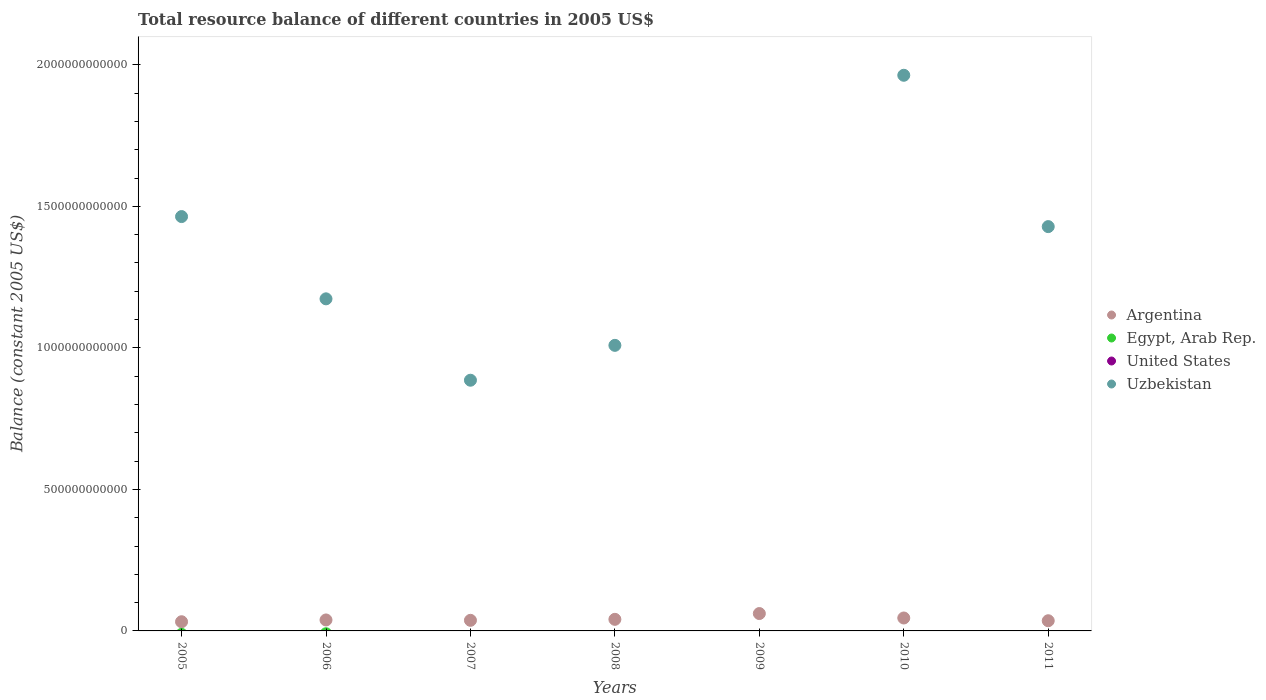How many different coloured dotlines are there?
Provide a succinct answer. 2. Is the number of dotlines equal to the number of legend labels?
Your answer should be compact. No. What is the total resource balance in Uzbekistan in 2005?
Make the answer very short. 1.46e+12. Across all years, what is the maximum total resource balance in Uzbekistan?
Give a very brief answer. 1.96e+12. Across all years, what is the minimum total resource balance in Egypt, Arab Rep.?
Offer a terse response. 0. What is the difference between the total resource balance in Argentina in 2008 and that in 2009?
Your answer should be very brief. -2.04e+1. What is the difference between the total resource balance in Uzbekistan in 2005 and the total resource balance in United States in 2007?
Your answer should be very brief. 1.46e+12. In the year 2010, what is the difference between the total resource balance in Uzbekistan and total resource balance in Argentina?
Provide a succinct answer. 1.92e+12. In how many years, is the total resource balance in Egypt, Arab Rep. greater than 100000000000 US$?
Keep it short and to the point. 0. What is the ratio of the total resource balance in Uzbekistan in 2005 to that in 2008?
Your answer should be very brief. 1.45. Is the total resource balance in Argentina in 2005 less than that in 2006?
Keep it short and to the point. Yes. What is the difference between the highest and the second highest total resource balance in Argentina?
Offer a very short reply. 1.57e+1. In how many years, is the total resource balance in Uzbekistan greater than the average total resource balance in Uzbekistan taken over all years?
Provide a succinct answer. 4. Is the sum of the total resource balance in Argentina in 2005 and 2008 greater than the maximum total resource balance in Egypt, Arab Rep. across all years?
Ensure brevity in your answer.  Yes. Is it the case that in every year, the sum of the total resource balance in Argentina and total resource balance in United States  is greater than the total resource balance in Egypt, Arab Rep.?
Provide a succinct answer. Yes. Does the total resource balance in Argentina monotonically increase over the years?
Keep it short and to the point. No. Is the total resource balance in Egypt, Arab Rep. strictly greater than the total resource balance in United States over the years?
Your response must be concise. Yes. What is the difference between two consecutive major ticks on the Y-axis?
Your answer should be very brief. 5.00e+11. Are the values on the major ticks of Y-axis written in scientific E-notation?
Provide a succinct answer. No. Does the graph contain any zero values?
Offer a terse response. Yes. Where does the legend appear in the graph?
Your answer should be compact. Center right. How are the legend labels stacked?
Give a very brief answer. Vertical. What is the title of the graph?
Your answer should be very brief. Total resource balance of different countries in 2005 US$. What is the label or title of the X-axis?
Make the answer very short. Years. What is the label or title of the Y-axis?
Your response must be concise. Balance (constant 2005 US$). What is the Balance (constant 2005 US$) of Argentina in 2005?
Provide a succinct answer. 3.24e+1. What is the Balance (constant 2005 US$) in Egypt, Arab Rep. in 2005?
Offer a terse response. 0. What is the Balance (constant 2005 US$) of Uzbekistan in 2005?
Make the answer very short. 1.46e+12. What is the Balance (constant 2005 US$) of Argentina in 2006?
Ensure brevity in your answer.  3.87e+1. What is the Balance (constant 2005 US$) in Egypt, Arab Rep. in 2006?
Give a very brief answer. 0. What is the Balance (constant 2005 US$) of Uzbekistan in 2006?
Your response must be concise. 1.17e+12. What is the Balance (constant 2005 US$) of Argentina in 2007?
Your response must be concise. 3.74e+1. What is the Balance (constant 2005 US$) in United States in 2007?
Make the answer very short. 0. What is the Balance (constant 2005 US$) of Uzbekistan in 2007?
Ensure brevity in your answer.  8.86e+11. What is the Balance (constant 2005 US$) in Argentina in 2008?
Provide a short and direct response. 4.09e+1. What is the Balance (constant 2005 US$) of Egypt, Arab Rep. in 2008?
Keep it short and to the point. 0. What is the Balance (constant 2005 US$) of United States in 2008?
Your answer should be compact. 0. What is the Balance (constant 2005 US$) of Uzbekistan in 2008?
Keep it short and to the point. 1.01e+12. What is the Balance (constant 2005 US$) of Argentina in 2009?
Your answer should be very brief. 6.14e+1. What is the Balance (constant 2005 US$) in Argentina in 2010?
Make the answer very short. 4.57e+1. What is the Balance (constant 2005 US$) in United States in 2010?
Provide a succinct answer. 0. What is the Balance (constant 2005 US$) in Uzbekistan in 2010?
Your answer should be compact. 1.96e+12. What is the Balance (constant 2005 US$) of Argentina in 2011?
Offer a very short reply. 3.60e+1. What is the Balance (constant 2005 US$) in Uzbekistan in 2011?
Your response must be concise. 1.43e+12. Across all years, what is the maximum Balance (constant 2005 US$) in Argentina?
Offer a terse response. 6.14e+1. Across all years, what is the maximum Balance (constant 2005 US$) of Uzbekistan?
Provide a succinct answer. 1.96e+12. Across all years, what is the minimum Balance (constant 2005 US$) of Argentina?
Make the answer very short. 3.24e+1. Across all years, what is the minimum Balance (constant 2005 US$) of Uzbekistan?
Your response must be concise. 0. What is the total Balance (constant 2005 US$) of Argentina in the graph?
Keep it short and to the point. 2.93e+11. What is the total Balance (constant 2005 US$) in Egypt, Arab Rep. in the graph?
Give a very brief answer. 0. What is the total Balance (constant 2005 US$) of Uzbekistan in the graph?
Your response must be concise. 7.92e+12. What is the difference between the Balance (constant 2005 US$) of Argentina in 2005 and that in 2006?
Your answer should be very brief. -6.29e+09. What is the difference between the Balance (constant 2005 US$) in Uzbekistan in 2005 and that in 2006?
Offer a very short reply. 2.91e+11. What is the difference between the Balance (constant 2005 US$) in Argentina in 2005 and that in 2007?
Ensure brevity in your answer.  -5.00e+09. What is the difference between the Balance (constant 2005 US$) of Uzbekistan in 2005 and that in 2007?
Your answer should be very brief. 5.78e+11. What is the difference between the Balance (constant 2005 US$) in Argentina in 2005 and that in 2008?
Offer a very short reply. -8.49e+09. What is the difference between the Balance (constant 2005 US$) in Uzbekistan in 2005 and that in 2008?
Make the answer very short. 4.55e+11. What is the difference between the Balance (constant 2005 US$) in Argentina in 2005 and that in 2009?
Make the answer very short. -2.89e+1. What is the difference between the Balance (constant 2005 US$) of Argentina in 2005 and that in 2010?
Your answer should be very brief. -1.33e+1. What is the difference between the Balance (constant 2005 US$) of Uzbekistan in 2005 and that in 2010?
Keep it short and to the point. -4.99e+11. What is the difference between the Balance (constant 2005 US$) of Argentina in 2005 and that in 2011?
Offer a terse response. -3.54e+09. What is the difference between the Balance (constant 2005 US$) in Uzbekistan in 2005 and that in 2011?
Your answer should be very brief. 3.55e+1. What is the difference between the Balance (constant 2005 US$) in Argentina in 2006 and that in 2007?
Your response must be concise. 1.29e+09. What is the difference between the Balance (constant 2005 US$) of Uzbekistan in 2006 and that in 2007?
Offer a very short reply. 2.88e+11. What is the difference between the Balance (constant 2005 US$) of Argentina in 2006 and that in 2008?
Provide a short and direct response. -2.20e+09. What is the difference between the Balance (constant 2005 US$) in Uzbekistan in 2006 and that in 2008?
Give a very brief answer. 1.64e+11. What is the difference between the Balance (constant 2005 US$) in Argentina in 2006 and that in 2009?
Keep it short and to the point. -2.26e+1. What is the difference between the Balance (constant 2005 US$) in Argentina in 2006 and that in 2010?
Offer a very short reply. -6.96e+09. What is the difference between the Balance (constant 2005 US$) in Uzbekistan in 2006 and that in 2010?
Your answer should be very brief. -7.90e+11. What is the difference between the Balance (constant 2005 US$) in Argentina in 2006 and that in 2011?
Your answer should be compact. 2.75e+09. What is the difference between the Balance (constant 2005 US$) in Uzbekistan in 2006 and that in 2011?
Your answer should be very brief. -2.55e+11. What is the difference between the Balance (constant 2005 US$) of Argentina in 2007 and that in 2008?
Provide a short and direct response. -3.49e+09. What is the difference between the Balance (constant 2005 US$) in Uzbekistan in 2007 and that in 2008?
Ensure brevity in your answer.  -1.23e+11. What is the difference between the Balance (constant 2005 US$) in Argentina in 2007 and that in 2009?
Your answer should be very brief. -2.39e+1. What is the difference between the Balance (constant 2005 US$) in Argentina in 2007 and that in 2010?
Offer a very short reply. -8.25e+09. What is the difference between the Balance (constant 2005 US$) in Uzbekistan in 2007 and that in 2010?
Your answer should be very brief. -1.08e+12. What is the difference between the Balance (constant 2005 US$) of Argentina in 2007 and that in 2011?
Your answer should be very brief. 1.47e+09. What is the difference between the Balance (constant 2005 US$) in Uzbekistan in 2007 and that in 2011?
Your answer should be compact. -5.43e+11. What is the difference between the Balance (constant 2005 US$) in Argentina in 2008 and that in 2009?
Your answer should be compact. -2.04e+1. What is the difference between the Balance (constant 2005 US$) of Argentina in 2008 and that in 2010?
Offer a terse response. -4.76e+09. What is the difference between the Balance (constant 2005 US$) of Uzbekistan in 2008 and that in 2010?
Keep it short and to the point. -9.54e+11. What is the difference between the Balance (constant 2005 US$) in Argentina in 2008 and that in 2011?
Provide a short and direct response. 4.96e+09. What is the difference between the Balance (constant 2005 US$) of Uzbekistan in 2008 and that in 2011?
Offer a terse response. -4.19e+11. What is the difference between the Balance (constant 2005 US$) of Argentina in 2009 and that in 2010?
Keep it short and to the point. 1.57e+1. What is the difference between the Balance (constant 2005 US$) in Argentina in 2009 and that in 2011?
Offer a very short reply. 2.54e+1. What is the difference between the Balance (constant 2005 US$) in Argentina in 2010 and that in 2011?
Offer a terse response. 9.71e+09. What is the difference between the Balance (constant 2005 US$) in Uzbekistan in 2010 and that in 2011?
Provide a succinct answer. 5.35e+11. What is the difference between the Balance (constant 2005 US$) in Argentina in 2005 and the Balance (constant 2005 US$) in Uzbekistan in 2006?
Your answer should be compact. -1.14e+12. What is the difference between the Balance (constant 2005 US$) in Argentina in 2005 and the Balance (constant 2005 US$) in Uzbekistan in 2007?
Your answer should be very brief. -8.53e+11. What is the difference between the Balance (constant 2005 US$) of Argentina in 2005 and the Balance (constant 2005 US$) of Uzbekistan in 2008?
Keep it short and to the point. -9.76e+11. What is the difference between the Balance (constant 2005 US$) in Argentina in 2005 and the Balance (constant 2005 US$) in Uzbekistan in 2010?
Your response must be concise. -1.93e+12. What is the difference between the Balance (constant 2005 US$) of Argentina in 2005 and the Balance (constant 2005 US$) of Uzbekistan in 2011?
Keep it short and to the point. -1.40e+12. What is the difference between the Balance (constant 2005 US$) of Argentina in 2006 and the Balance (constant 2005 US$) of Uzbekistan in 2007?
Your answer should be compact. -8.47e+11. What is the difference between the Balance (constant 2005 US$) in Argentina in 2006 and the Balance (constant 2005 US$) in Uzbekistan in 2008?
Offer a very short reply. -9.70e+11. What is the difference between the Balance (constant 2005 US$) of Argentina in 2006 and the Balance (constant 2005 US$) of Uzbekistan in 2010?
Offer a terse response. -1.92e+12. What is the difference between the Balance (constant 2005 US$) in Argentina in 2006 and the Balance (constant 2005 US$) in Uzbekistan in 2011?
Provide a succinct answer. -1.39e+12. What is the difference between the Balance (constant 2005 US$) in Argentina in 2007 and the Balance (constant 2005 US$) in Uzbekistan in 2008?
Make the answer very short. -9.71e+11. What is the difference between the Balance (constant 2005 US$) of Argentina in 2007 and the Balance (constant 2005 US$) of Uzbekistan in 2010?
Make the answer very short. -1.93e+12. What is the difference between the Balance (constant 2005 US$) of Argentina in 2007 and the Balance (constant 2005 US$) of Uzbekistan in 2011?
Your response must be concise. -1.39e+12. What is the difference between the Balance (constant 2005 US$) in Argentina in 2008 and the Balance (constant 2005 US$) in Uzbekistan in 2010?
Keep it short and to the point. -1.92e+12. What is the difference between the Balance (constant 2005 US$) in Argentina in 2008 and the Balance (constant 2005 US$) in Uzbekistan in 2011?
Give a very brief answer. -1.39e+12. What is the difference between the Balance (constant 2005 US$) in Argentina in 2009 and the Balance (constant 2005 US$) in Uzbekistan in 2010?
Your answer should be compact. -1.90e+12. What is the difference between the Balance (constant 2005 US$) of Argentina in 2009 and the Balance (constant 2005 US$) of Uzbekistan in 2011?
Keep it short and to the point. -1.37e+12. What is the difference between the Balance (constant 2005 US$) in Argentina in 2010 and the Balance (constant 2005 US$) in Uzbekistan in 2011?
Keep it short and to the point. -1.38e+12. What is the average Balance (constant 2005 US$) of Argentina per year?
Keep it short and to the point. 4.18e+1. What is the average Balance (constant 2005 US$) in Uzbekistan per year?
Make the answer very short. 1.13e+12. In the year 2005, what is the difference between the Balance (constant 2005 US$) of Argentina and Balance (constant 2005 US$) of Uzbekistan?
Offer a terse response. -1.43e+12. In the year 2006, what is the difference between the Balance (constant 2005 US$) in Argentina and Balance (constant 2005 US$) in Uzbekistan?
Your answer should be very brief. -1.13e+12. In the year 2007, what is the difference between the Balance (constant 2005 US$) in Argentina and Balance (constant 2005 US$) in Uzbekistan?
Ensure brevity in your answer.  -8.48e+11. In the year 2008, what is the difference between the Balance (constant 2005 US$) in Argentina and Balance (constant 2005 US$) in Uzbekistan?
Your answer should be compact. -9.68e+11. In the year 2010, what is the difference between the Balance (constant 2005 US$) of Argentina and Balance (constant 2005 US$) of Uzbekistan?
Your response must be concise. -1.92e+12. In the year 2011, what is the difference between the Balance (constant 2005 US$) in Argentina and Balance (constant 2005 US$) in Uzbekistan?
Give a very brief answer. -1.39e+12. What is the ratio of the Balance (constant 2005 US$) in Argentina in 2005 to that in 2006?
Make the answer very short. 0.84. What is the ratio of the Balance (constant 2005 US$) in Uzbekistan in 2005 to that in 2006?
Ensure brevity in your answer.  1.25. What is the ratio of the Balance (constant 2005 US$) in Argentina in 2005 to that in 2007?
Make the answer very short. 0.87. What is the ratio of the Balance (constant 2005 US$) in Uzbekistan in 2005 to that in 2007?
Provide a short and direct response. 1.65. What is the ratio of the Balance (constant 2005 US$) in Argentina in 2005 to that in 2008?
Offer a very short reply. 0.79. What is the ratio of the Balance (constant 2005 US$) in Uzbekistan in 2005 to that in 2008?
Your answer should be compact. 1.45. What is the ratio of the Balance (constant 2005 US$) of Argentina in 2005 to that in 2009?
Your answer should be very brief. 0.53. What is the ratio of the Balance (constant 2005 US$) of Argentina in 2005 to that in 2010?
Ensure brevity in your answer.  0.71. What is the ratio of the Balance (constant 2005 US$) of Uzbekistan in 2005 to that in 2010?
Keep it short and to the point. 0.75. What is the ratio of the Balance (constant 2005 US$) of Argentina in 2005 to that in 2011?
Ensure brevity in your answer.  0.9. What is the ratio of the Balance (constant 2005 US$) in Uzbekistan in 2005 to that in 2011?
Offer a terse response. 1.02. What is the ratio of the Balance (constant 2005 US$) in Argentina in 2006 to that in 2007?
Make the answer very short. 1.03. What is the ratio of the Balance (constant 2005 US$) of Uzbekistan in 2006 to that in 2007?
Ensure brevity in your answer.  1.32. What is the ratio of the Balance (constant 2005 US$) of Argentina in 2006 to that in 2008?
Keep it short and to the point. 0.95. What is the ratio of the Balance (constant 2005 US$) of Uzbekistan in 2006 to that in 2008?
Keep it short and to the point. 1.16. What is the ratio of the Balance (constant 2005 US$) in Argentina in 2006 to that in 2009?
Your response must be concise. 0.63. What is the ratio of the Balance (constant 2005 US$) of Argentina in 2006 to that in 2010?
Provide a short and direct response. 0.85. What is the ratio of the Balance (constant 2005 US$) of Uzbekistan in 2006 to that in 2010?
Give a very brief answer. 0.6. What is the ratio of the Balance (constant 2005 US$) in Argentina in 2006 to that in 2011?
Your answer should be compact. 1.08. What is the ratio of the Balance (constant 2005 US$) of Uzbekistan in 2006 to that in 2011?
Keep it short and to the point. 0.82. What is the ratio of the Balance (constant 2005 US$) of Argentina in 2007 to that in 2008?
Provide a short and direct response. 0.91. What is the ratio of the Balance (constant 2005 US$) of Uzbekistan in 2007 to that in 2008?
Your answer should be very brief. 0.88. What is the ratio of the Balance (constant 2005 US$) of Argentina in 2007 to that in 2009?
Offer a very short reply. 0.61. What is the ratio of the Balance (constant 2005 US$) in Argentina in 2007 to that in 2010?
Your response must be concise. 0.82. What is the ratio of the Balance (constant 2005 US$) of Uzbekistan in 2007 to that in 2010?
Provide a succinct answer. 0.45. What is the ratio of the Balance (constant 2005 US$) of Argentina in 2007 to that in 2011?
Offer a terse response. 1.04. What is the ratio of the Balance (constant 2005 US$) of Uzbekistan in 2007 to that in 2011?
Give a very brief answer. 0.62. What is the ratio of the Balance (constant 2005 US$) of Argentina in 2008 to that in 2009?
Offer a terse response. 0.67. What is the ratio of the Balance (constant 2005 US$) in Argentina in 2008 to that in 2010?
Offer a very short reply. 0.9. What is the ratio of the Balance (constant 2005 US$) in Uzbekistan in 2008 to that in 2010?
Offer a very short reply. 0.51. What is the ratio of the Balance (constant 2005 US$) of Argentina in 2008 to that in 2011?
Your response must be concise. 1.14. What is the ratio of the Balance (constant 2005 US$) of Uzbekistan in 2008 to that in 2011?
Provide a short and direct response. 0.71. What is the ratio of the Balance (constant 2005 US$) of Argentina in 2009 to that in 2010?
Your response must be concise. 1.34. What is the ratio of the Balance (constant 2005 US$) in Argentina in 2009 to that in 2011?
Your answer should be very brief. 1.71. What is the ratio of the Balance (constant 2005 US$) of Argentina in 2010 to that in 2011?
Keep it short and to the point. 1.27. What is the ratio of the Balance (constant 2005 US$) of Uzbekistan in 2010 to that in 2011?
Your answer should be very brief. 1.37. What is the difference between the highest and the second highest Balance (constant 2005 US$) of Argentina?
Your answer should be compact. 1.57e+1. What is the difference between the highest and the second highest Balance (constant 2005 US$) of Uzbekistan?
Your answer should be very brief. 4.99e+11. What is the difference between the highest and the lowest Balance (constant 2005 US$) in Argentina?
Keep it short and to the point. 2.89e+1. What is the difference between the highest and the lowest Balance (constant 2005 US$) in Uzbekistan?
Offer a terse response. 1.96e+12. 